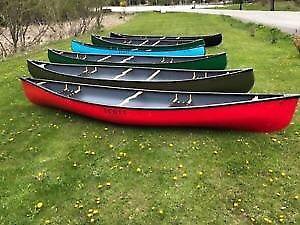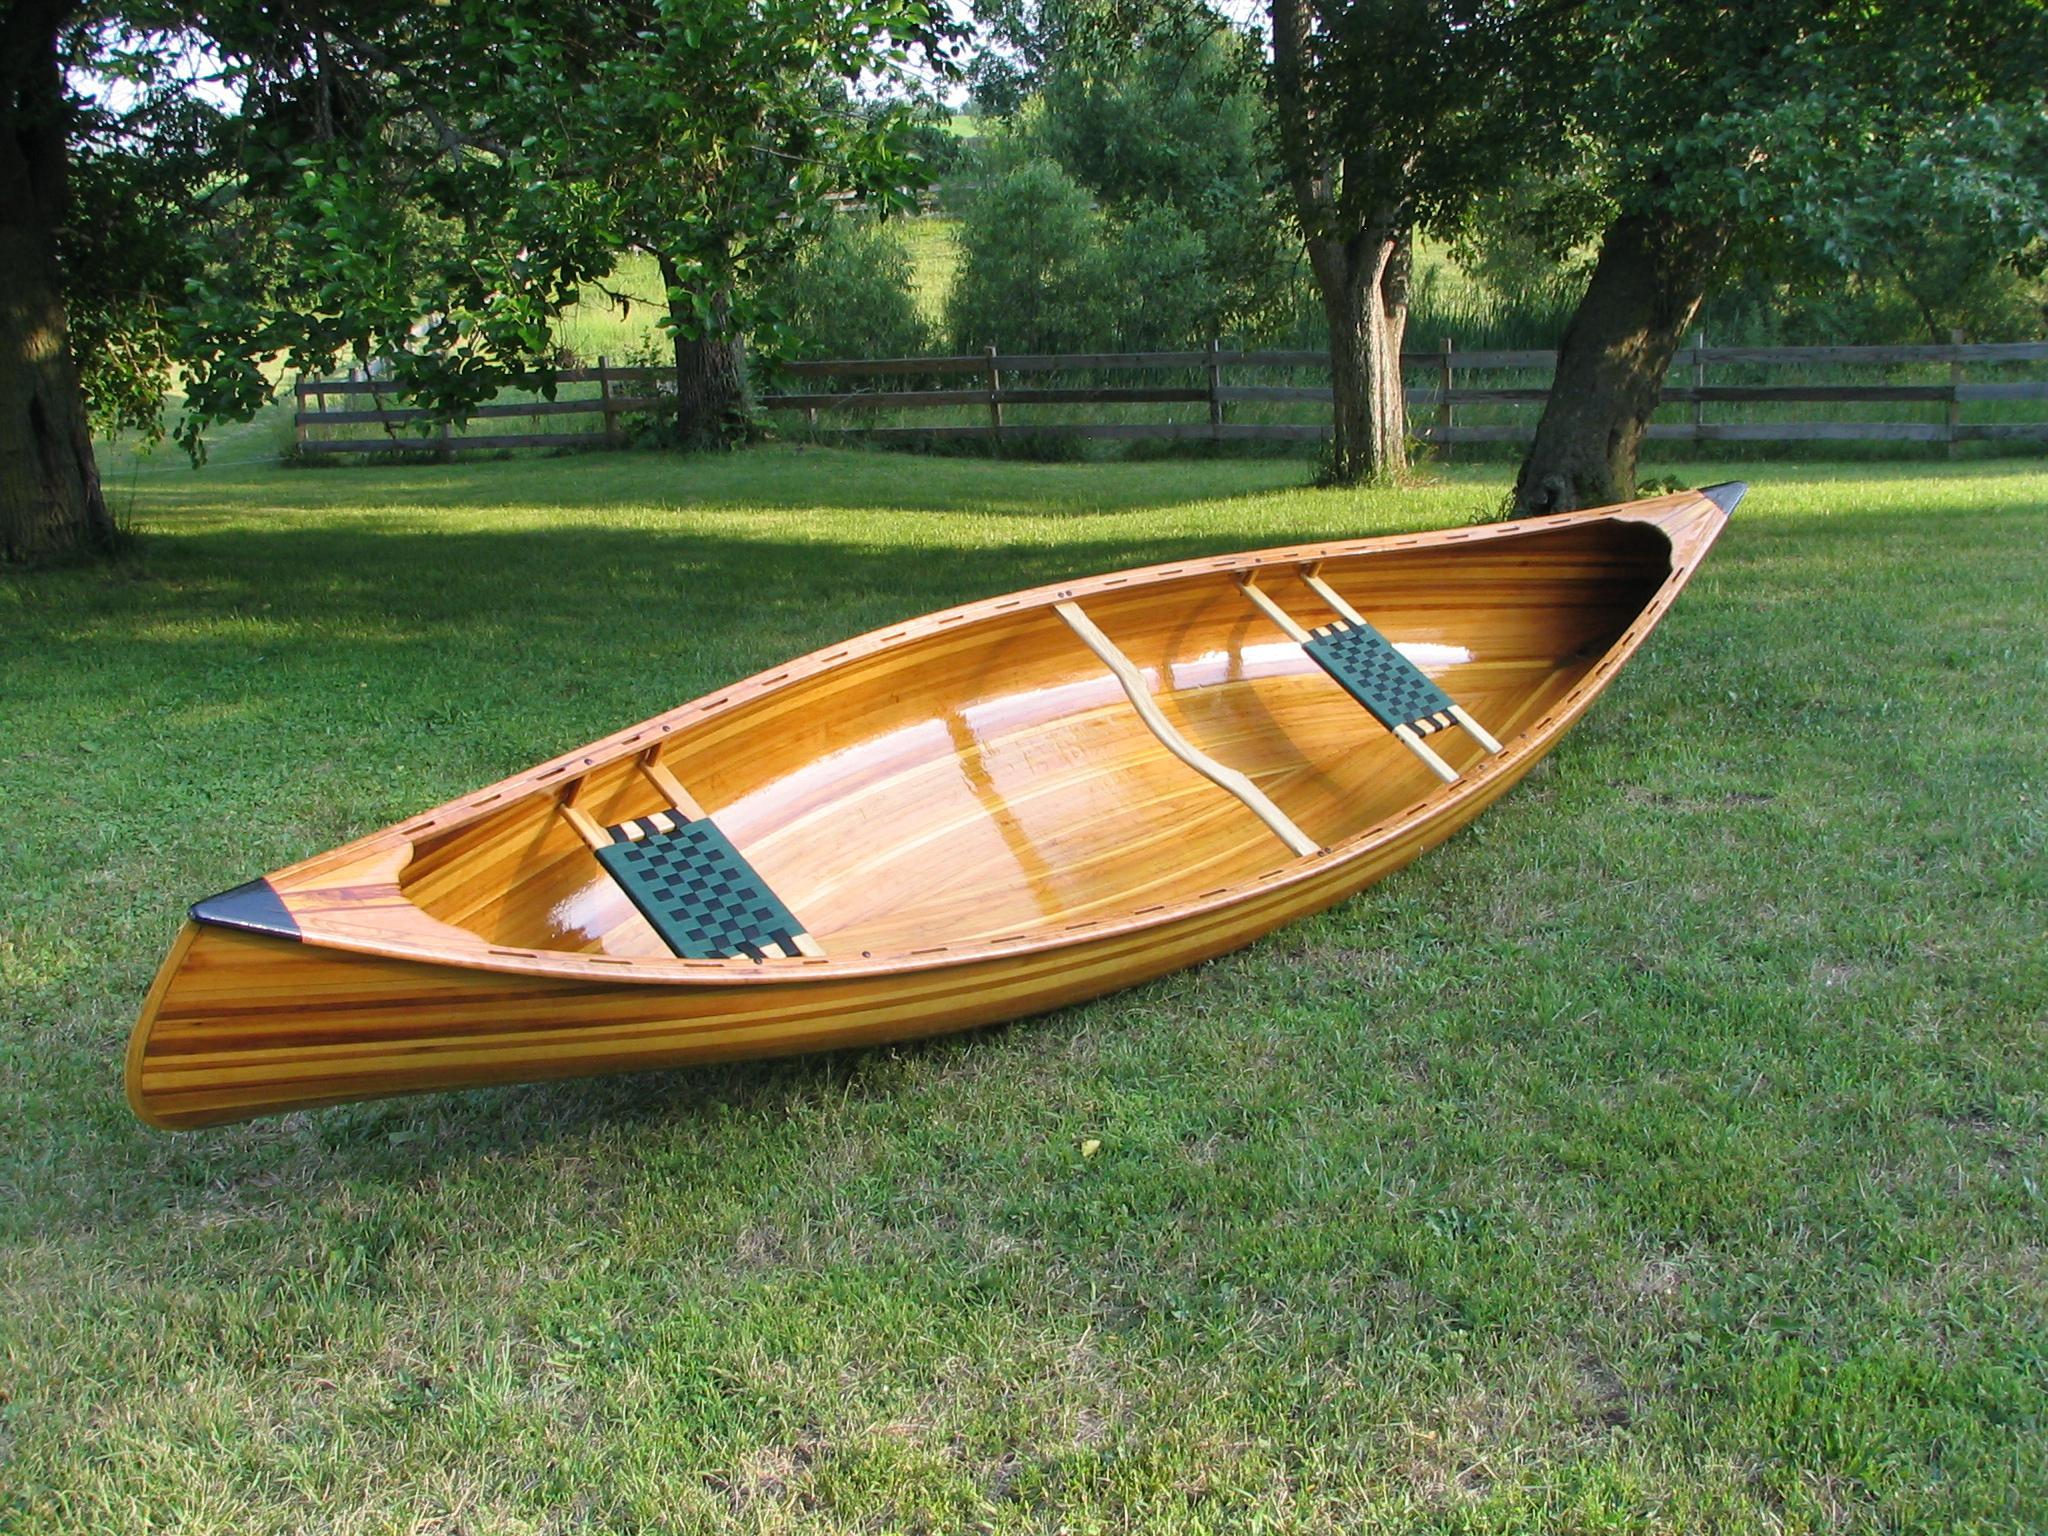The first image is the image on the left, the second image is the image on the right. Given the left and right images, does the statement "An image shows one canoe pulled up to the edge of a body of water." hold true? Answer yes or no. No. The first image is the image on the left, the second image is the image on the right. Considering the images on both sides, is "In one image a single wooden canoe is angled to show the fine wood grain of its interior, while a second image shows one or more painted canoes on grass." valid? Answer yes or no. Yes. 